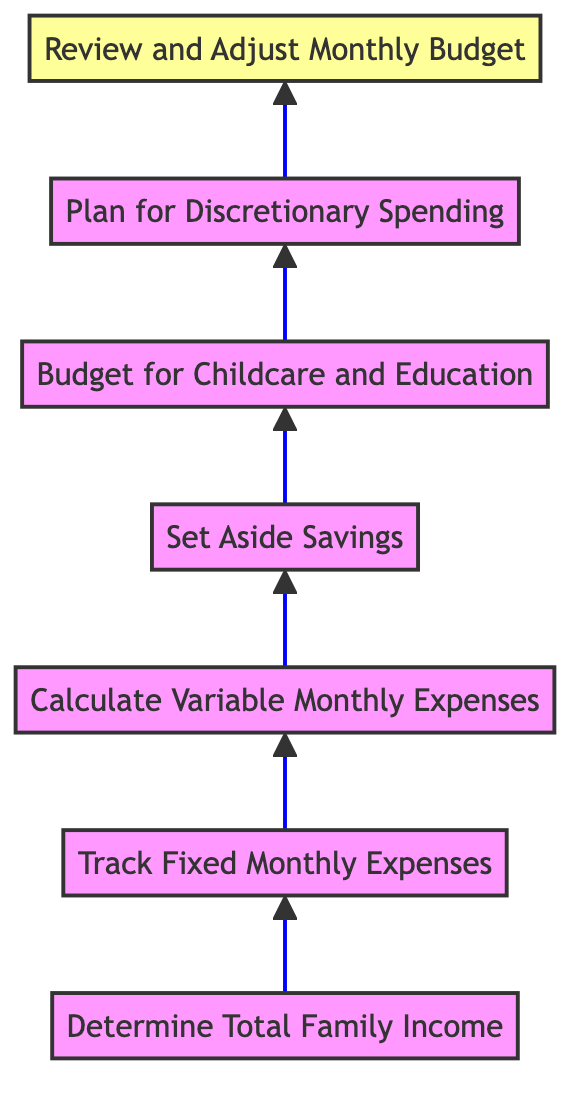What is the first step in monthly budget management? The first step indicated in the diagram is "Determine Total Family Income," which is the starting point of the budgeting process.
Answer: Determine Total Family Income How many total nodes are in the diagram? The diagram consists of 7 nodes, each representing a step in the monthly budget management process.
Answer: 7 What does the last step in the diagram entail? The last step is "Review and Adjust Monthly Budget," which means to evaluate and modify the budget based on actual spending.
Answer: Review and Adjust Monthly Budget Which step follows "Calculate Variable Monthly Expenses"? According to the flow of the diagram, the step that follows "Calculate Variable Monthly Expenses" is "Set Aside Savings."
Answer: Set Aside Savings What is the relationship between "Budget for Childcare and Education" and "Plan for Discretionary Spending"? "Budget for Childcare and Education" directly precedes "Plan for Discretionary Spending," indicating that both are steps in allocating a family's expenses, with the former coming before the latter.
Answer: Directly precedes How many categories of expenses are tracked in the budgeting process according to the diagram? The diagram outlines three categories of expenses: Fixed Monthly Expenses, Variable Monthly Expenses, and Discretionary Spending, indicating a total of three.
Answer: Three Which step requires monitoring actual spending? The step that requires monitoring is "Review and Adjust Monthly Budget," as it focuses on comparing budgeted amounts with actual expenses.
Answer: Review and Adjust Monthly Budget What is the function of "Set Aside Savings" in the overall budget flow? "Set Aside Savings" functions as a critical step to ensure that a portion of income is directed towards savings before other expenses are allocated.
Answer: Ensure savings 